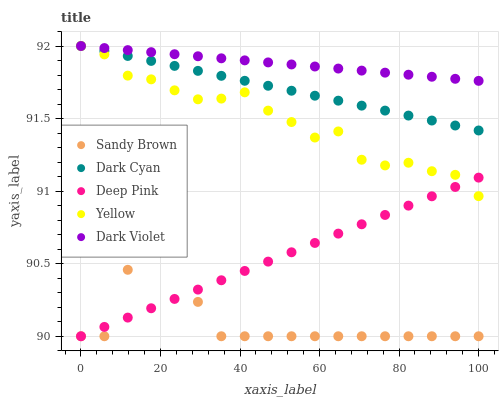Does Sandy Brown have the minimum area under the curve?
Answer yes or no. Yes. Does Dark Violet have the maximum area under the curve?
Answer yes or no. Yes. Does Deep Pink have the minimum area under the curve?
Answer yes or no. No. Does Deep Pink have the maximum area under the curve?
Answer yes or no. No. Is Deep Pink the smoothest?
Answer yes or no. Yes. Is Sandy Brown the roughest?
Answer yes or no. Yes. Is Sandy Brown the smoothest?
Answer yes or no. No. Is Deep Pink the roughest?
Answer yes or no. No. Does Deep Pink have the lowest value?
Answer yes or no. Yes. Does Dark Violet have the lowest value?
Answer yes or no. No. Does Yellow have the highest value?
Answer yes or no. Yes. Does Deep Pink have the highest value?
Answer yes or no. No. Is Sandy Brown less than Dark Cyan?
Answer yes or no. Yes. Is Dark Violet greater than Sandy Brown?
Answer yes or no. Yes. Does Yellow intersect Dark Violet?
Answer yes or no. Yes. Is Yellow less than Dark Violet?
Answer yes or no. No. Is Yellow greater than Dark Violet?
Answer yes or no. No. Does Sandy Brown intersect Dark Cyan?
Answer yes or no. No. 